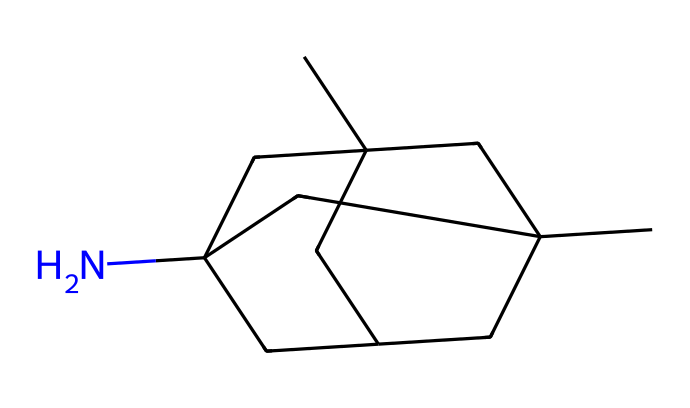How many nitrogen atoms are present in memantine? The SMILES representation shows one nitrogen atom in the structure, indicated by the "N" in the sequence.
Answer: one What is the total number of carbon atoms in the molecular structure? By analyzing the SMILES string, there are 11 carbon atoms represented by the "C" symbols throughout the structure.
Answer: eleven What functional group is indicated in this chemical's structure? The presence of a nitrogen atom (N) indicates the presence of an amine functional group, which is typical for memantine, as it contains a nitrogen in its structure.
Answer: amine Is memantine classified as a nitrile? Although the name includes the term "nitrile," this specific structure does not depict a nitrile since nitriles consist of a carbon triple-bonded to a nitrogen. Instead, it features an amine without the nitrile characteristic.
Answer: no How many rings are present in the memantine structure? The structure has two distinct cyclic sections, which can be accounted for by observing the specific points in the SMILES where cyclic bonding occurs, identified by numbers indicating the starting and closing of rings.
Answer: two 